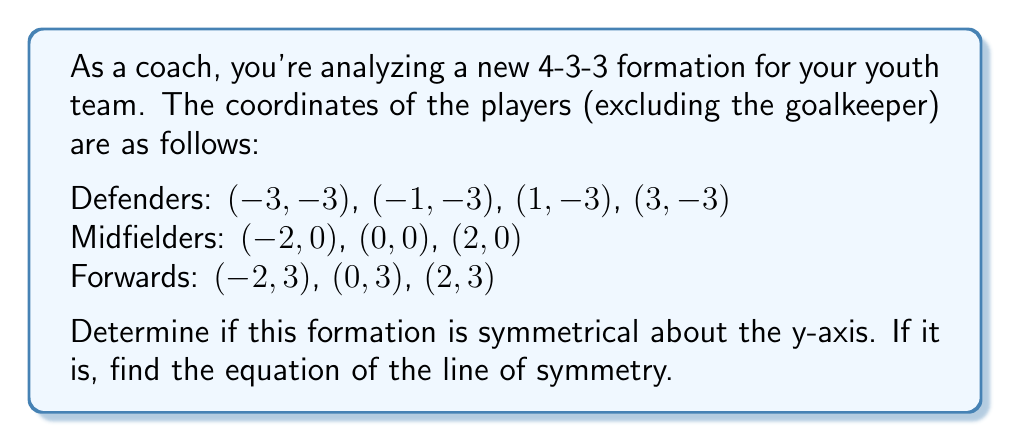Can you solve this math problem? To determine if the formation is symmetrical about the y-axis, we need to check if each player has a corresponding player reflected across the y-axis.

1. First, let's examine the x-coordinates of all players:
   Defenders: $-3, -1, 1, 3$
   Midfielders: $-2, 0, 2$
   Forwards: $-2, 0, 2$

2. We can see that for each x-coordinate, there is a corresponding negative value (except for 0, which is its own reflection).

3. Now, let's check if the y-coordinates remain the same for each pair of reflected points:
   Defenders: All have y-coordinate $-3$
   Midfielders: All have y-coordinate $0$
   Forwards: All have y-coordinate $3$

4. Since the y-coordinates are the same for each pair of reflected points, and all x-coordinates have corresponding negative values, the formation is indeed symmetrical about the y-axis.

5. The equation of the y-axis (which is the line of symmetry in this case) is:

   $$x = 0$$

This line passes through the center midfielder and the center forward, dividing the formation into two equal halves.
Answer: Yes, the formation is symmetrical about the y-axis. The equation of the line of symmetry is $x = 0$. 